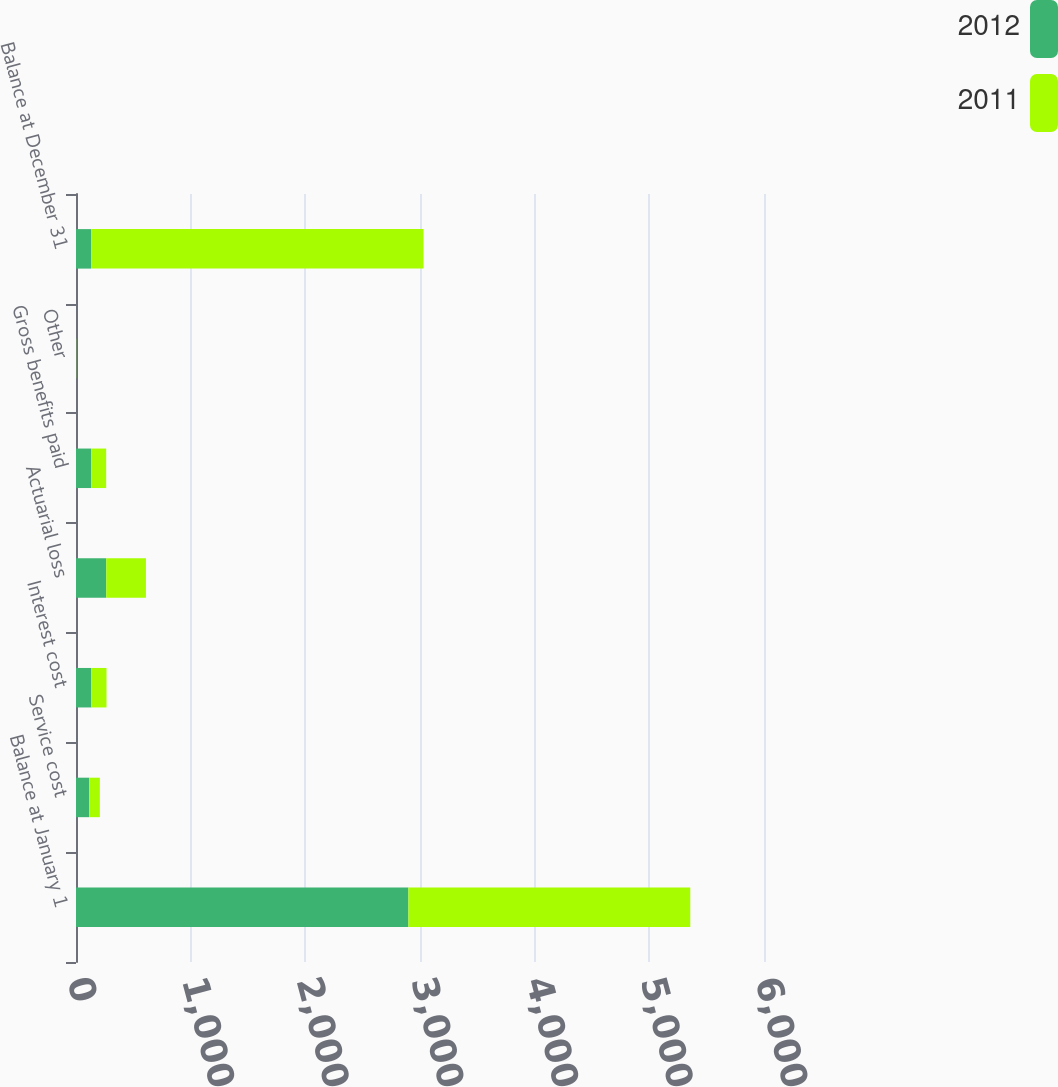Convert chart. <chart><loc_0><loc_0><loc_500><loc_500><stacked_bar_chart><ecel><fcel>Balance at January 1<fcel>Service cost<fcel>Interest cost<fcel>Actuarial loss<fcel>Gross benefits paid<fcel>Other<fcel>Balance at December 31<nl><fcel>2012<fcel>2899<fcel>115<fcel>134<fcel>264<fcel>132<fcel>1<fcel>132<nl><fcel>2011<fcel>2458<fcel>93<fcel>132<fcel>346<fcel>131<fcel>1<fcel>2899<nl></chart> 